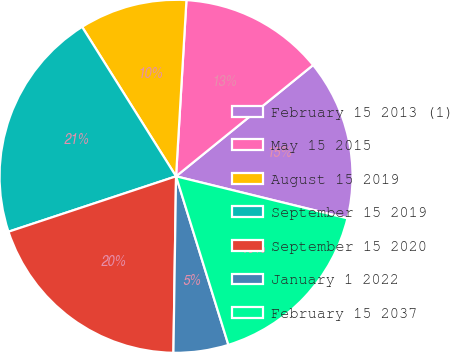Convert chart. <chart><loc_0><loc_0><loc_500><loc_500><pie_chart><fcel>February 15 2013 (1)<fcel>May 15 2015<fcel>August 15 2019<fcel>September 15 2019<fcel>September 15 2020<fcel>January 1 2022<fcel>February 15 2037<nl><fcel>14.68%<fcel>13.21%<fcel>9.87%<fcel>21.15%<fcel>19.68%<fcel>5.03%<fcel>16.38%<nl></chart> 